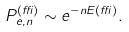<formula> <loc_0><loc_0><loc_500><loc_500>P _ { e , n } ^ { ( \delta ) } \sim e ^ { - n E ( \delta ) } .</formula> 